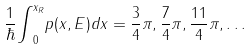Convert formula to latex. <formula><loc_0><loc_0><loc_500><loc_500>\frac { 1 } { \hbar } { \int } _ { 0 } ^ { x _ { R } } p ( x , E ) d x = \frac { 3 } { 4 } \pi , \frac { 7 } { 4 } \pi , \frac { 1 1 } 4 \pi , \dots</formula> 